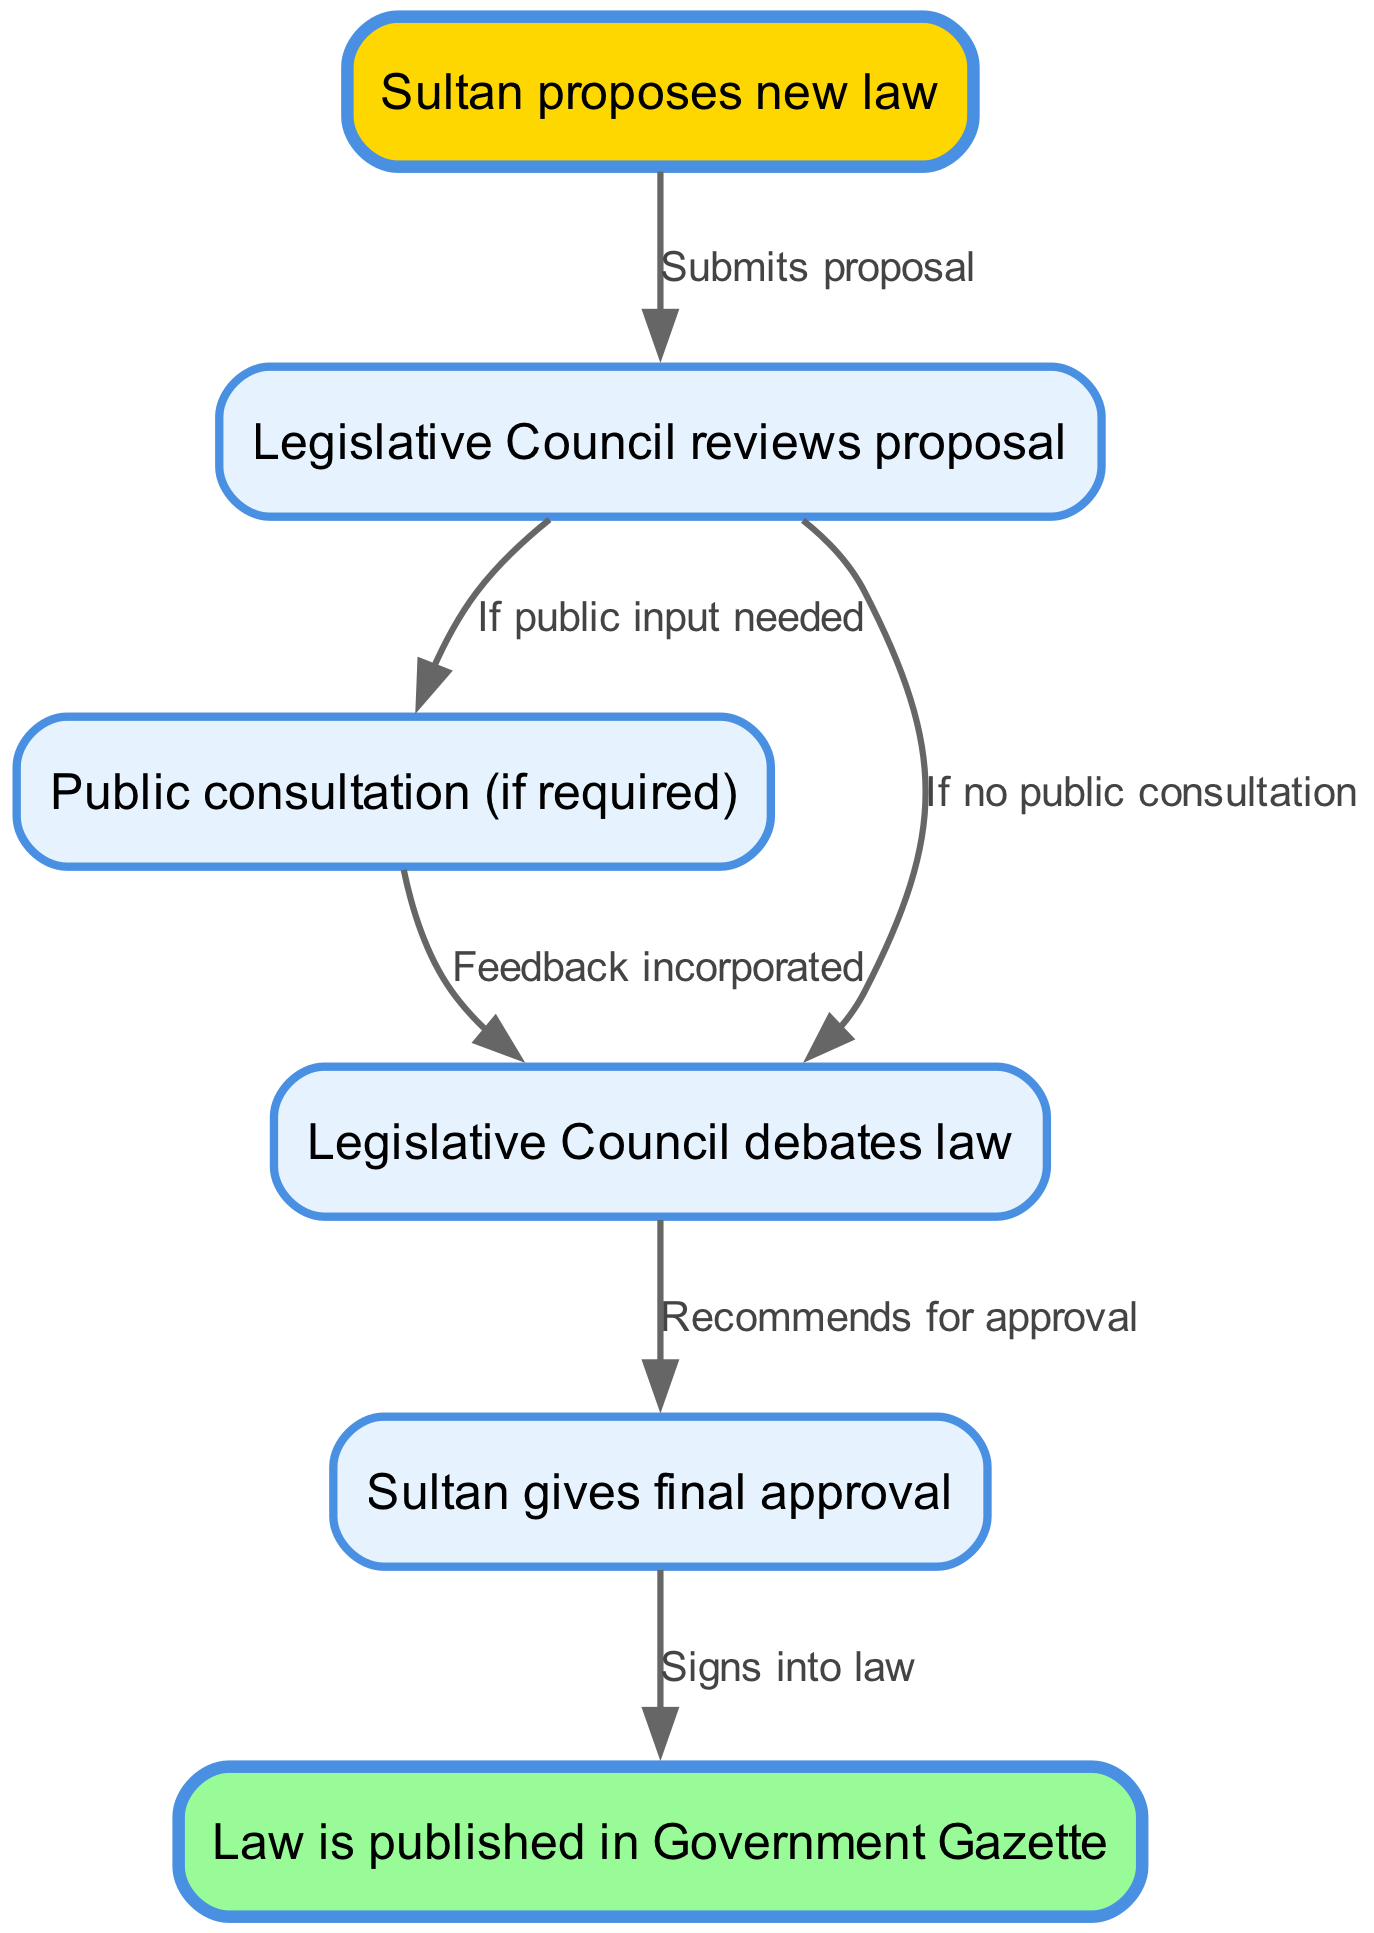What is the first step in the legislative process? The first step in the diagram shows that the Sultan proposes a new law. This is indicated by the node labeled "Sultan proposes new law."
Answer: Sultan proposes new law How many nodes are present in the diagram? By counting the distinct nodes in the flowchart, we find six nodes: the Sultan’s proposal, Legislative Council reviews, public consultation, Legislative Council debates, Sultan's approval, and law publication. Thus, there are six nodes in total.
Answer: 6 What happens after the Legislative Council reviews the proposal? After the Legislative Council reviews the proposal, it leads to either a public consultation, if needed, or directly to a debate on the law. This pathway is represented in the diagram with specific edges pointing to the respective nodes.
Answer: Public consultation (if required) or Legislative Council debates law What does the Legislative Council do after debating the law? The Legislative Council recommends the law for approval after conducting debates. This action is shown in the edge labeled "Recommends for approval" connecting the debate node to the Sultan's approval node.
Answer: Recommends for approval What is indicated by the final step of the diagram? The last step in the flowchart indicates that the Sultan signs the law into effect. This is shown in the node labeled "Signs into law," which is the final action required to complete the legislative process.
Answer: Signs into law What are the two possible paths after the Legislative Council reviews the proposal? The Legislative Council can either go to public consultation if public input is needed or move directly to the debate on the law. This bifurcation is depicted by the two edges originating from the review node, showing the decision-making process.
Answer: Public consultation or debates law What action follows the Sultan giving final approval? Once the Sultan gives final approval, the following action is that the law is published in the Government Gazette. This is indicated by the edge leading from the approval node to the publication node in the diagram.
Answer: Law is published in Government Gazette How does public consultation fit into the process? Public consultation is an optional step that takes place after the Legislative Council reviews the proposal, but only if public input is deemed necessary. This is represented in the flowchart as a conditional path emerging from the review node.
Answer: Optional step after review 